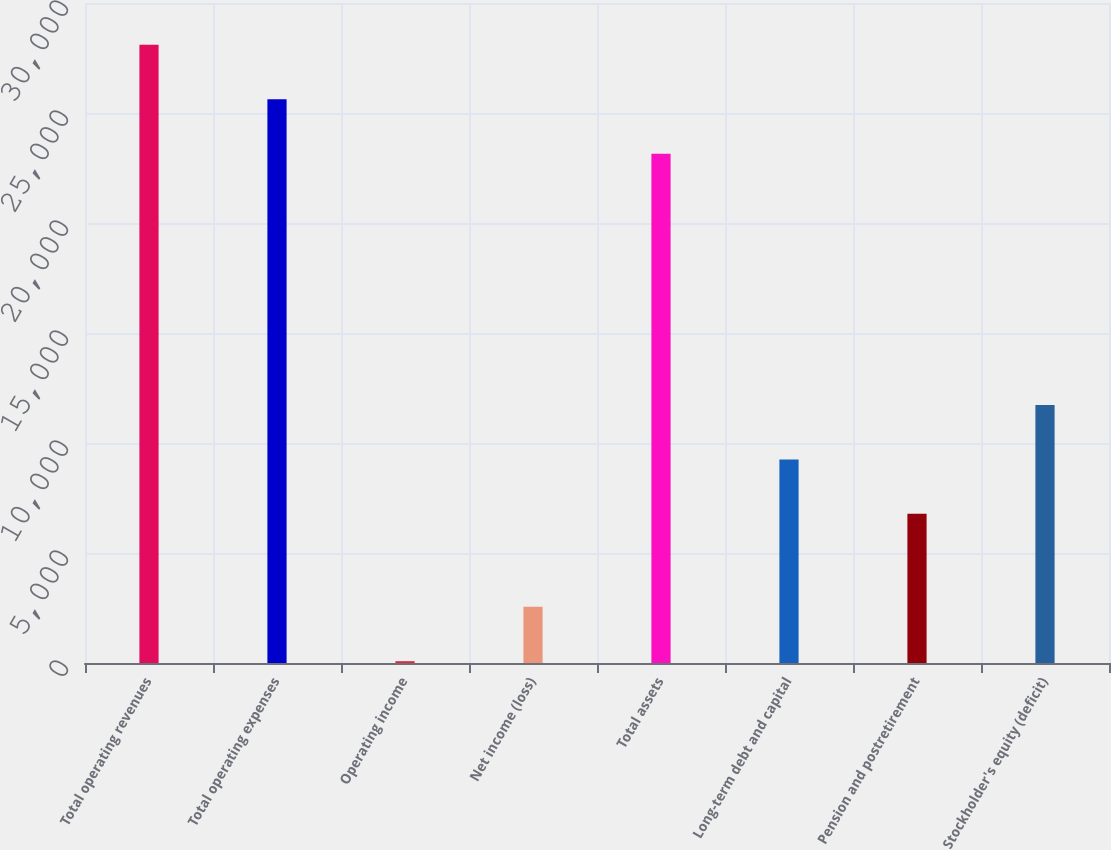<chart> <loc_0><loc_0><loc_500><loc_500><bar_chart><fcel>Total operating revenues<fcel>Total operating expenses<fcel>Operating income<fcel>Net income (loss)<fcel>Total assets<fcel>Long-term debt and capital<fcel>Pension and postretirement<fcel>Stockholder's equity (deficit)<nl><fcel>28098.6<fcel>25624.3<fcel>82<fcel>2556.3<fcel>23150<fcel>9254.3<fcel>6780<fcel>11728.6<nl></chart> 